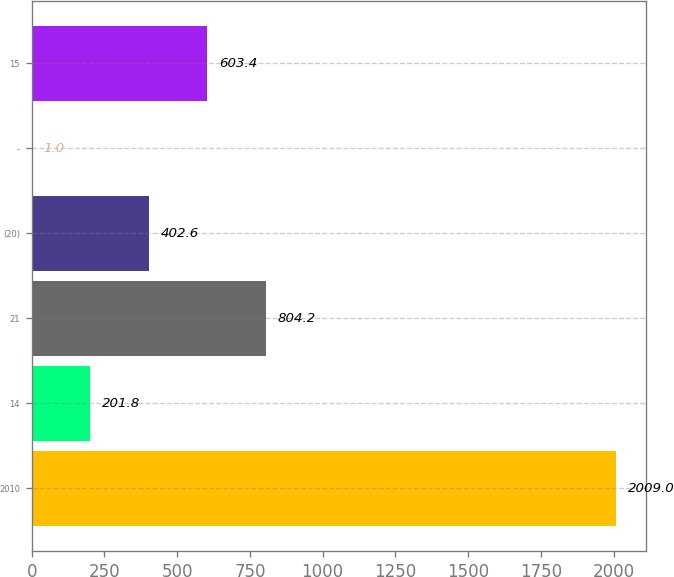Convert chart to OTSL. <chart><loc_0><loc_0><loc_500><loc_500><bar_chart><fcel>2010<fcel>14<fcel>21<fcel>(20)<fcel>-<fcel>15<nl><fcel>2009<fcel>201.8<fcel>804.2<fcel>402.6<fcel>1<fcel>603.4<nl></chart> 